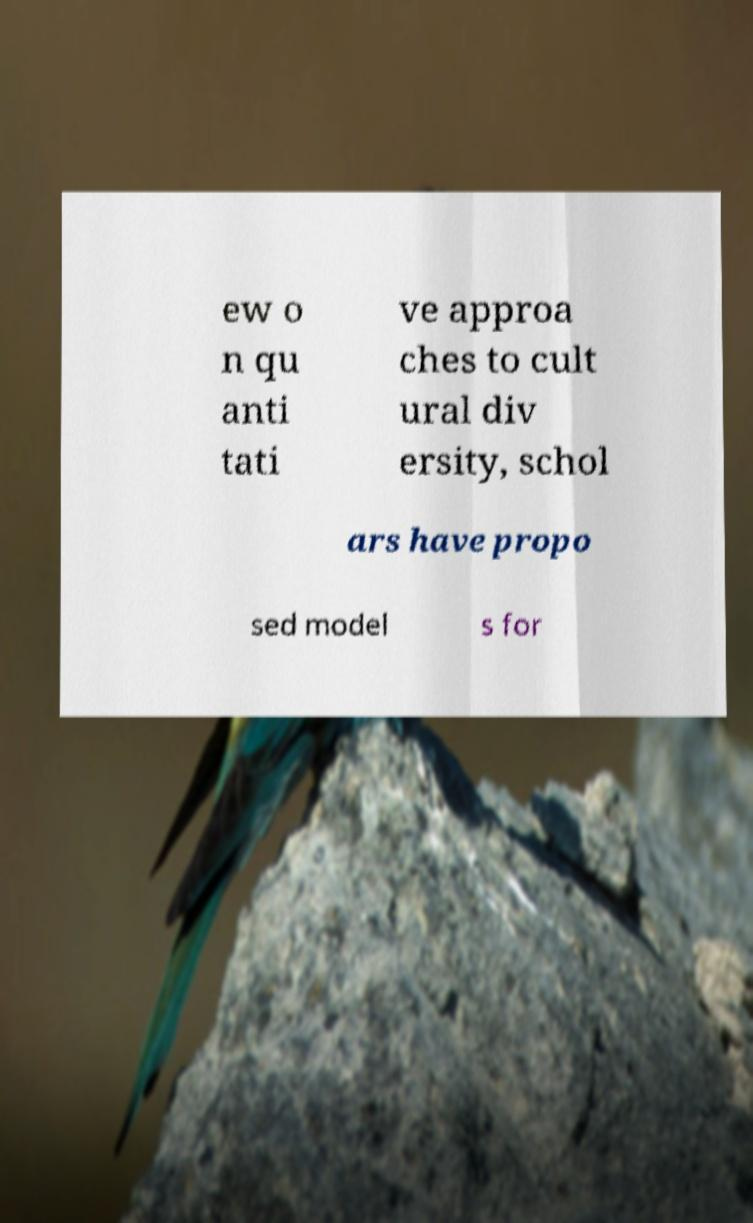I need the written content from this picture converted into text. Can you do that? ew o n qu anti tati ve approa ches to cult ural div ersity, schol ars have propo sed model s for 